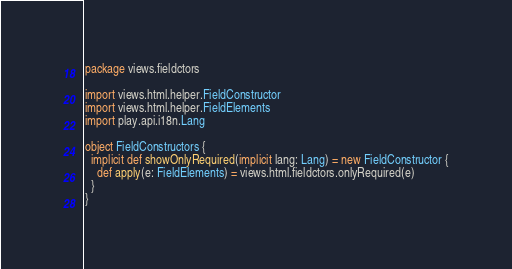<code> <loc_0><loc_0><loc_500><loc_500><_Scala_>package views.fieldctors

import views.html.helper.FieldConstructor
import views.html.helper.FieldElements
import play.api.i18n.Lang

object FieldConstructors {
  implicit def showOnlyRequired(implicit lang: Lang) = new FieldConstructor {
    def apply(e: FieldElements) = views.html.fieldctors.onlyRequired(e)
  }
}
</code> 